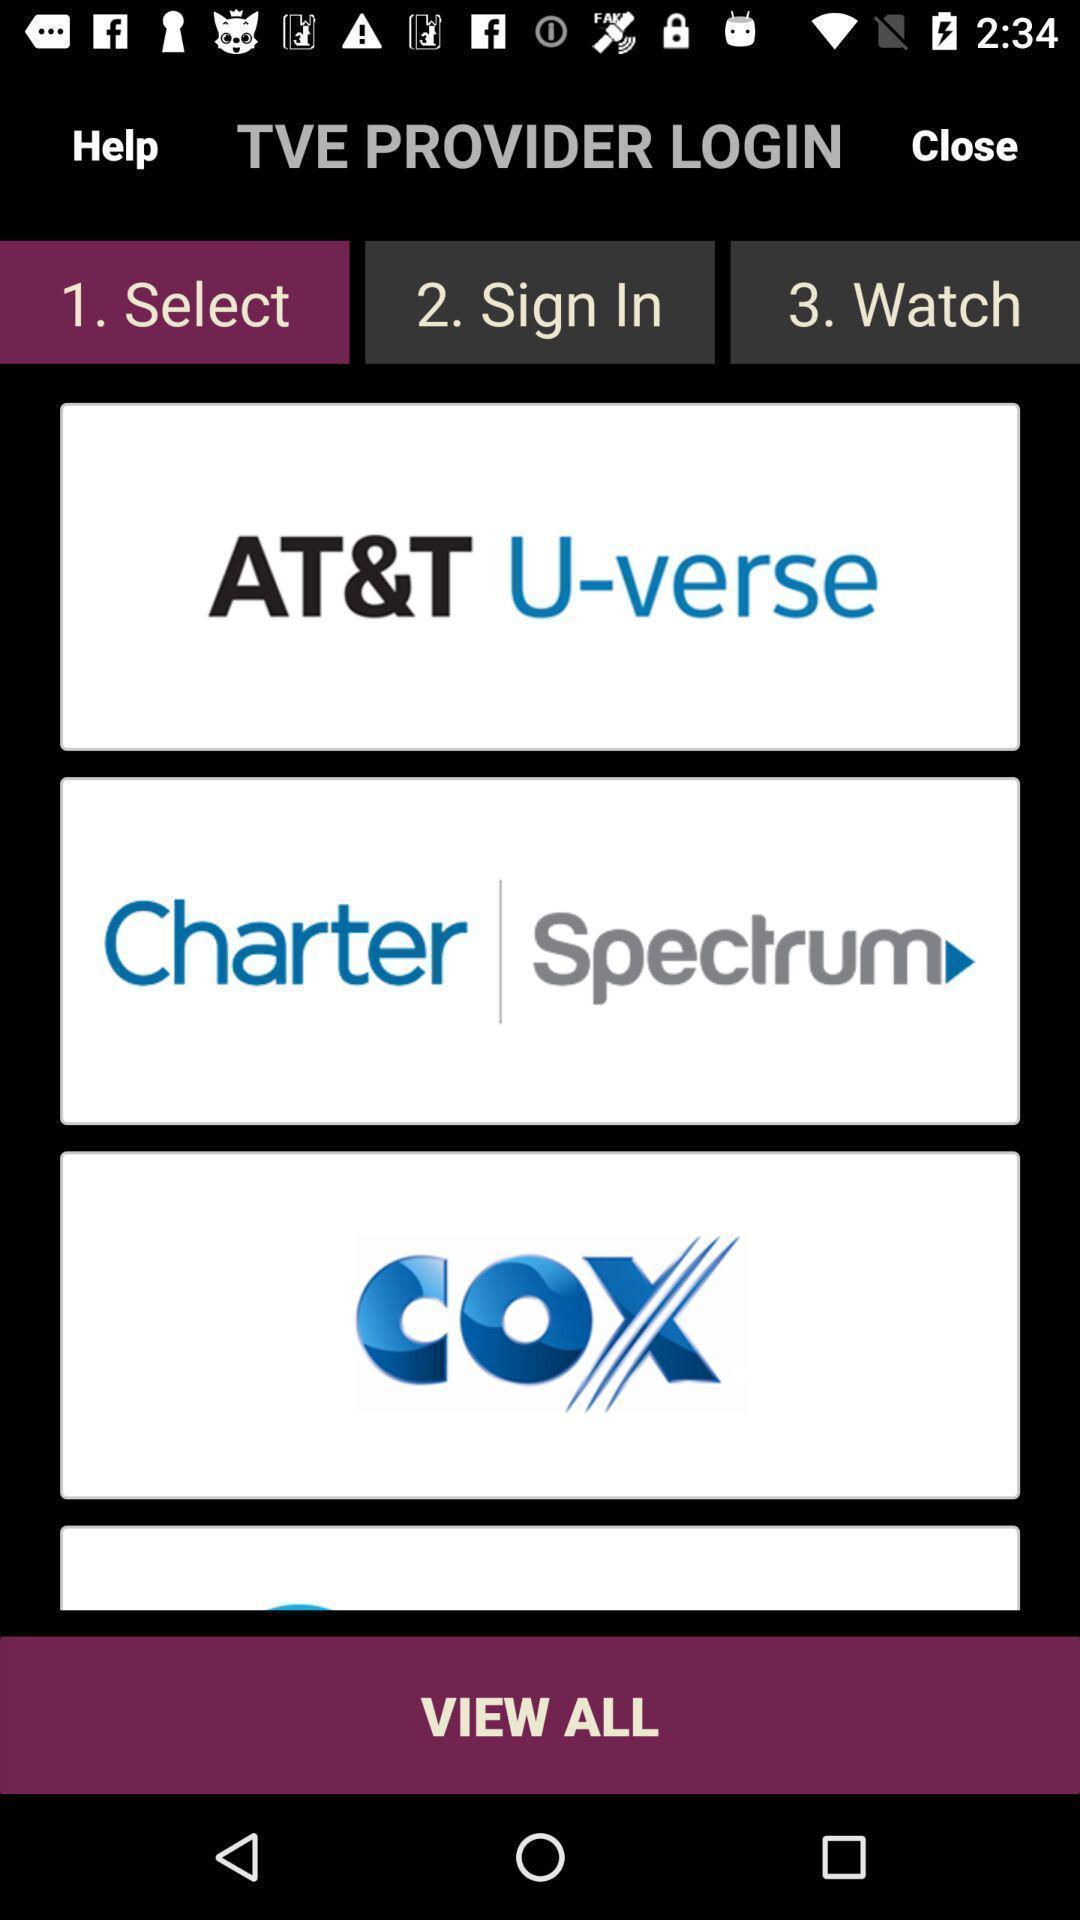Describe this image in words. Page showing the options in streaming app. 